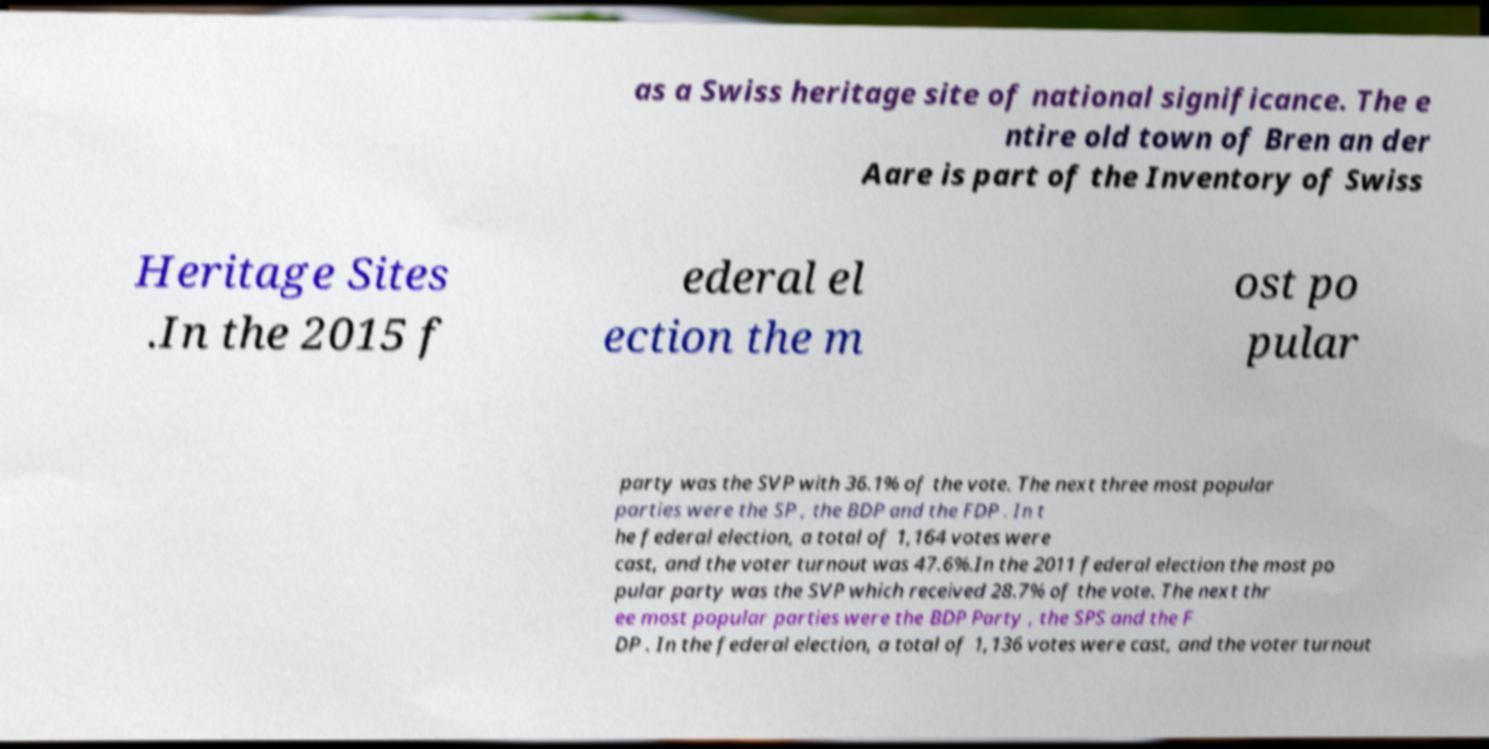Can you accurately transcribe the text from the provided image for me? as a Swiss heritage site of national significance. The e ntire old town of Bren an der Aare is part of the Inventory of Swiss Heritage Sites .In the 2015 f ederal el ection the m ost po pular party was the SVP with 36.1% of the vote. The next three most popular parties were the SP , the BDP and the FDP . In t he federal election, a total of 1,164 votes were cast, and the voter turnout was 47.6%.In the 2011 federal election the most po pular party was the SVP which received 28.7% of the vote. The next thr ee most popular parties were the BDP Party , the SPS and the F DP . In the federal election, a total of 1,136 votes were cast, and the voter turnout 